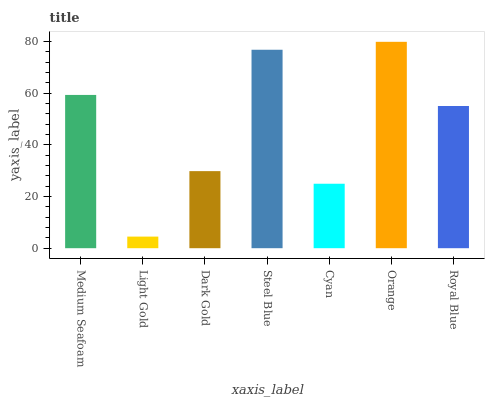Is Light Gold the minimum?
Answer yes or no. Yes. Is Orange the maximum?
Answer yes or no. Yes. Is Dark Gold the minimum?
Answer yes or no. No. Is Dark Gold the maximum?
Answer yes or no. No. Is Dark Gold greater than Light Gold?
Answer yes or no. Yes. Is Light Gold less than Dark Gold?
Answer yes or no. Yes. Is Light Gold greater than Dark Gold?
Answer yes or no. No. Is Dark Gold less than Light Gold?
Answer yes or no. No. Is Royal Blue the high median?
Answer yes or no. Yes. Is Royal Blue the low median?
Answer yes or no. Yes. Is Orange the high median?
Answer yes or no. No. Is Dark Gold the low median?
Answer yes or no. No. 